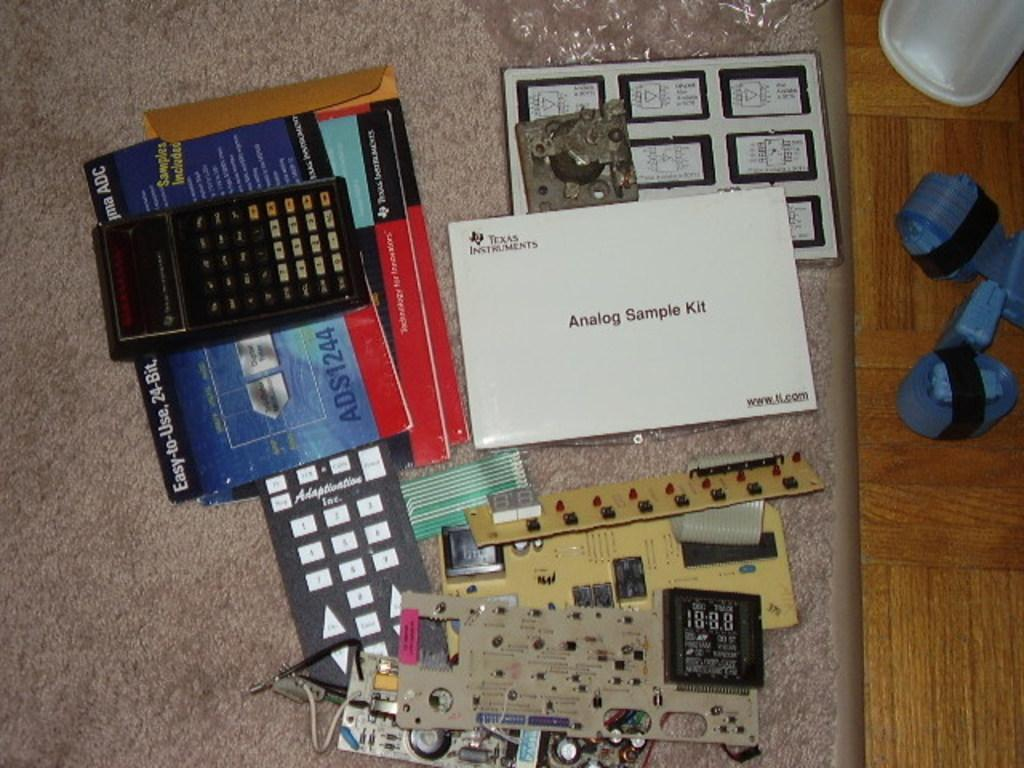<image>
Create a compact narrative representing the image presented. An Analog Sample Kit from Texas Instruments contains a lot of items for tinkering and learning. 